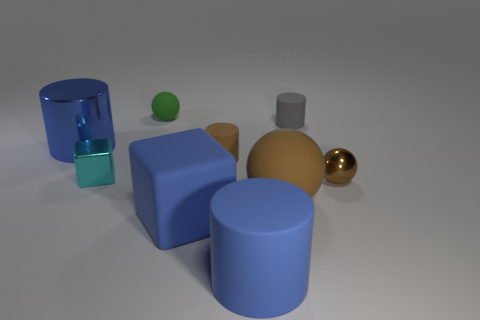Subtract all rubber balls. How many balls are left? 1 Add 1 yellow matte balls. How many objects exist? 10 Subtract all brown spheres. How many spheres are left? 1 Subtract all spheres. How many objects are left? 6 Subtract all blue cylinders. How many gray blocks are left? 0 Subtract all red balls. Subtract all yellow cubes. How many balls are left? 3 Subtract all brown shiny things. Subtract all tiny yellow balls. How many objects are left? 8 Add 7 small green matte objects. How many small green matte objects are left? 8 Add 8 big blue cylinders. How many big blue cylinders exist? 10 Subtract 0 brown blocks. How many objects are left? 9 